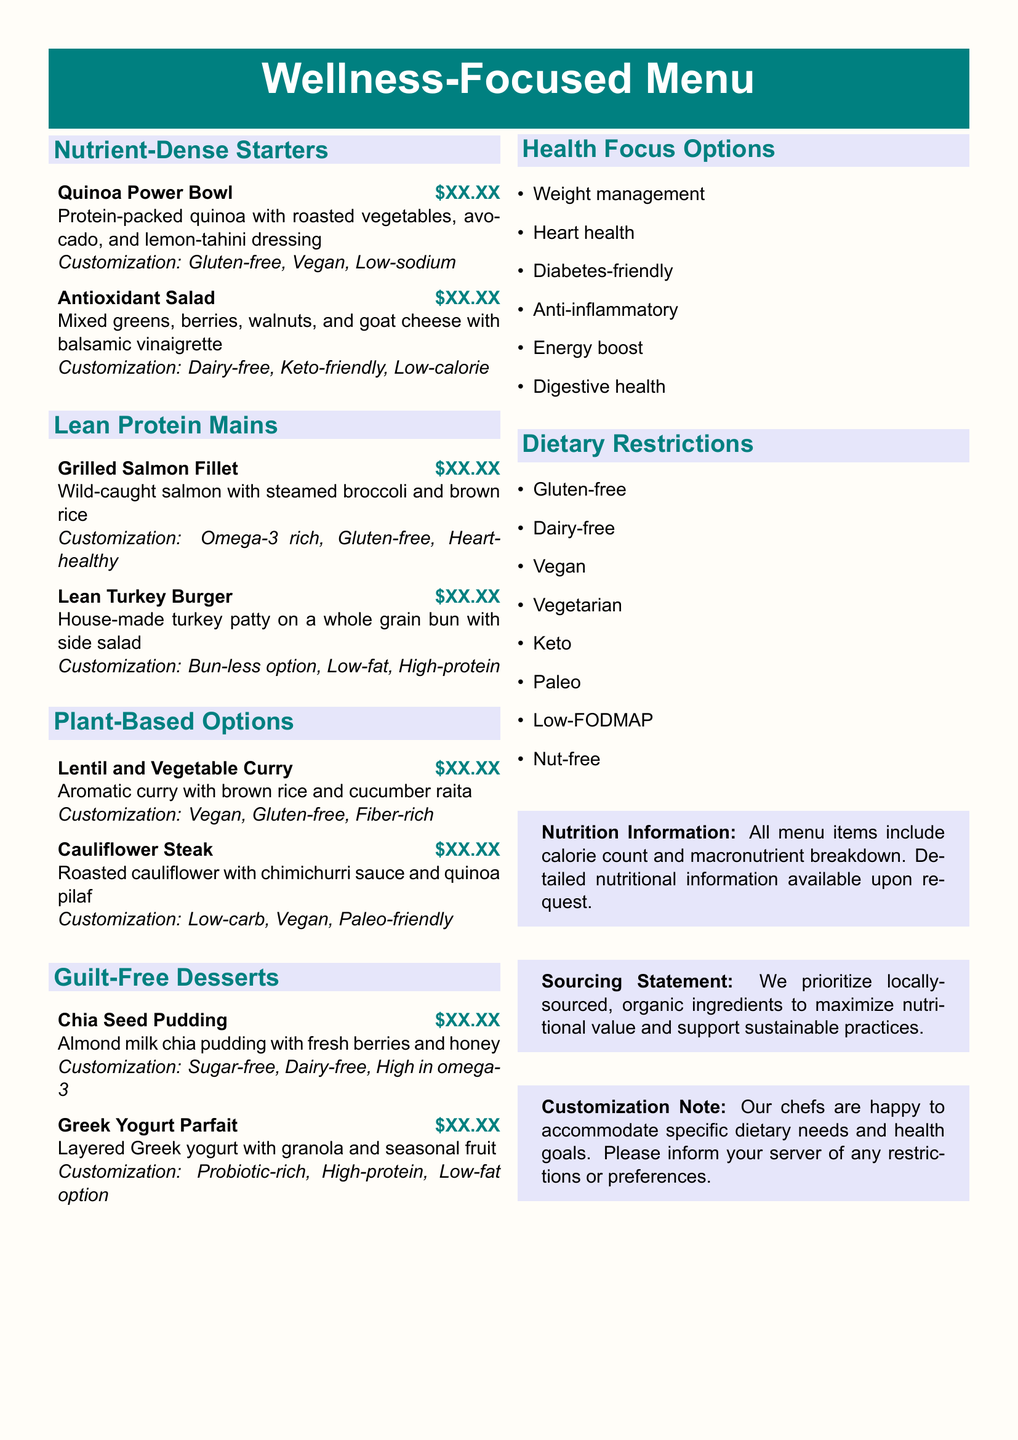what is the first item in the Nutrient-Dense Starters section? The first item listed under Nutrient-Dense Starters is Quinoa Power Bowl.
Answer: Quinoa Power Bowl which dish is dairy-free in the Lean Protein Mains? The Lean Protein Mains section has a dish that is specifically dairy-free, which is the Grilled Salmon Fillet.
Answer: Grilled Salmon Fillet how many desserts are listed on the menu? There are two desserts listed in the Guilt-Free Desserts section.
Answer: 2 which option is suitable for weight management? The menu provides health focus options, including weight management. The items can be customized for this goal.
Answer: Weight management is the Antioxidant Salad suitable for a Keto diet? The Antioxidant Salad is indicated as Keto-friendly, making it suitable for someone following a Keto diet.
Answer: Keto-friendly what customization option is available for the Lean Turkey Burger? A customization option for the Lean Turkey Burger is the Bun-less option.
Answer: Bun-less option which cuisine is featured in the Plant-Based Options section? The Plant-Based Options section features vegetarian dishes, specifically with lentils and cauliflower.
Answer: Vegetarian how does the restaurant support sustainable practices? The menu states that the restaurant prioritizes locally-sourced and organic ingredients to support sustainable practices.
Answer: Locally-sourced, organic ingredients 